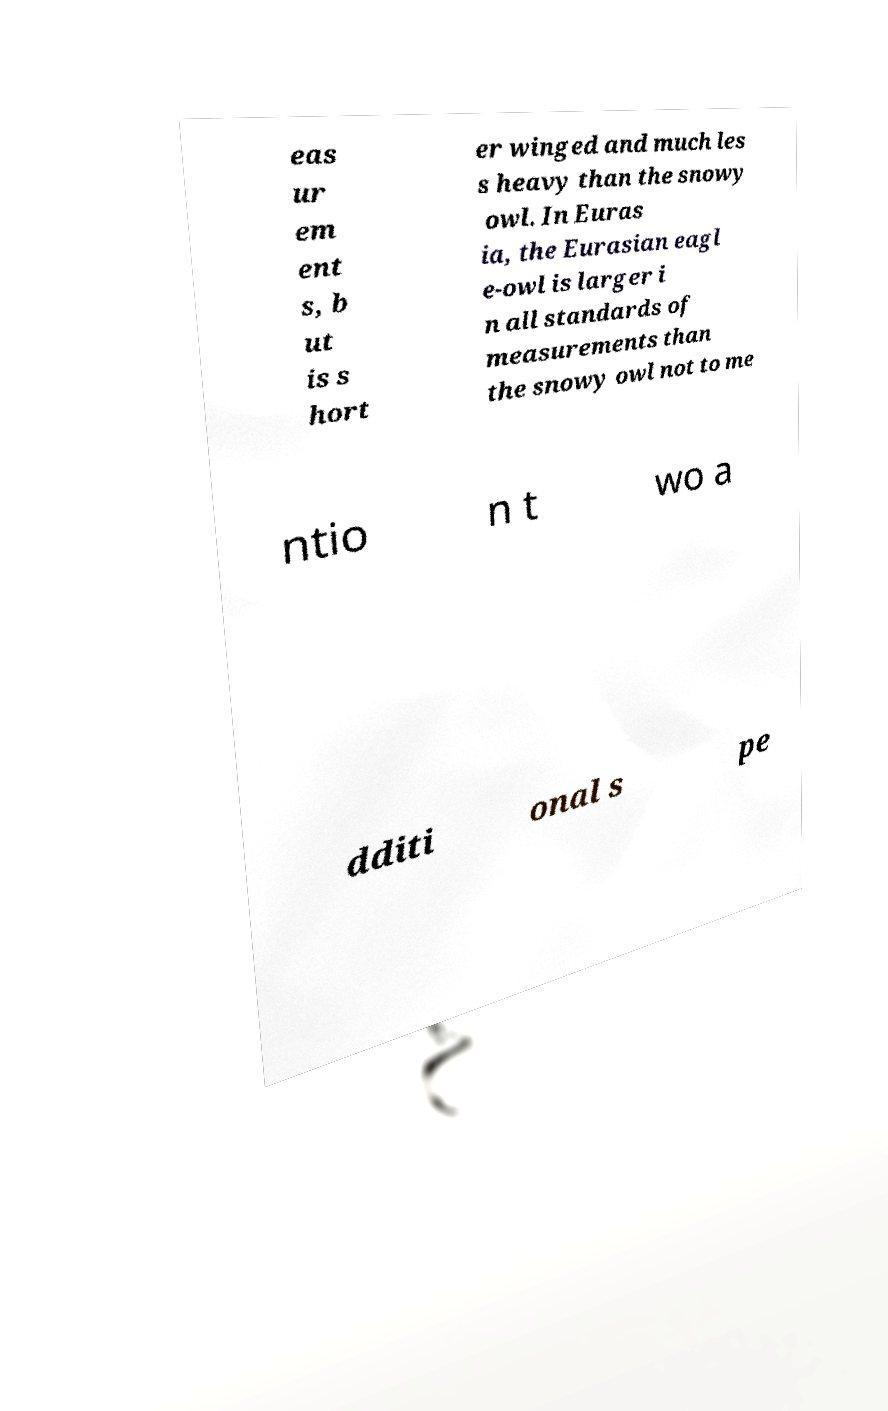I need the written content from this picture converted into text. Can you do that? eas ur em ent s, b ut is s hort er winged and much les s heavy than the snowy owl. In Euras ia, the Eurasian eagl e-owl is larger i n all standards of measurements than the snowy owl not to me ntio n t wo a dditi onal s pe 